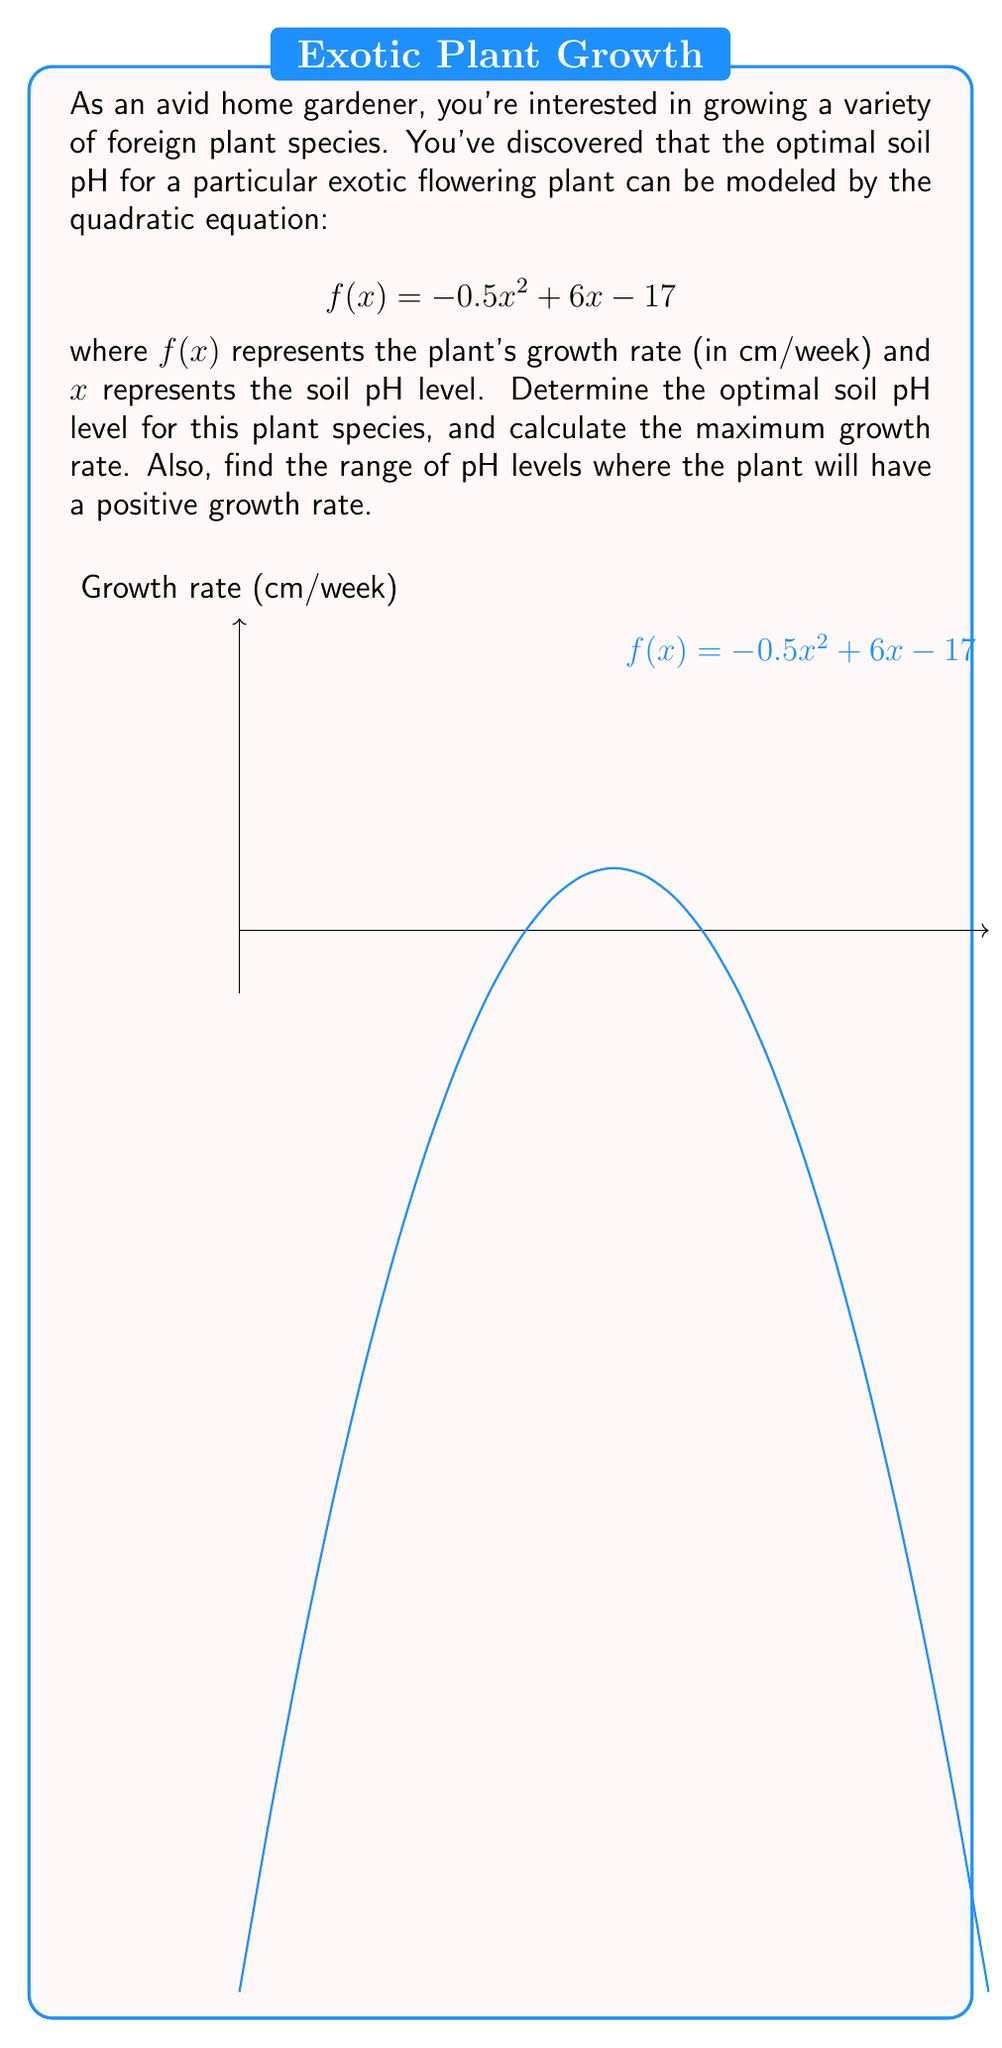Can you answer this question? Let's approach this step-by-step:

1) To find the optimal soil pH level, we need to find the vertex of the parabola. For a quadratic equation in the form $f(x) = ax^2 + bx + c$, the x-coordinate of the vertex is given by $x = -\frac{b}{2a}$.

2) In our equation $f(x) = -0.5x^2 + 6x - 17$, we have $a = -0.5$ and $b = 6$. So:

   $$x = -\frac{6}{2(-0.5)} = -\frac{6}{-1} = 6$$

3) Therefore, the optimal soil pH level is 6.

4) To find the maximum growth rate, we substitute x = 6 into the original equation:

   $$f(6) = -0.5(6)^2 + 6(6) - 17$$
   $$= -0.5(36) + 36 - 17$$
   $$= -18 + 36 - 17$$
   $$= 1$$

5) The maximum growth rate is 1 cm/week.

6) To find the range of pH levels where the plant will have a positive growth rate, we need to solve the equation $f(x) = 0$:

   $$-0.5x^2 + 6x - 17 = 0$$

7) We can solve this using the quadratic formula: $x = \frac{-b \pm \sqrt{b^2 - 4ac}}{2a}$

   $$x = \frac{-6 \pm \sqrt{6^2 - 4(-0.5)(-17)}}{2(-0.5)}$$
   $$= \frac{-6 \pm \sqrt{36 - 34}}{-1}$$
   $$= \frac{-6 \pm \sqrt{2}}{-1}$$

8) Solving this gives us:
   $$x_1 \approx 4.59 \text{ and } x_2 \approx 7.41$$

9) The plant will have a positive growth rate between these two pH levels.
Answer: Optimal pH: 6; Maximum growth rate: 1 cm/week; Positive growth pH range: 4.59 to 7.41 